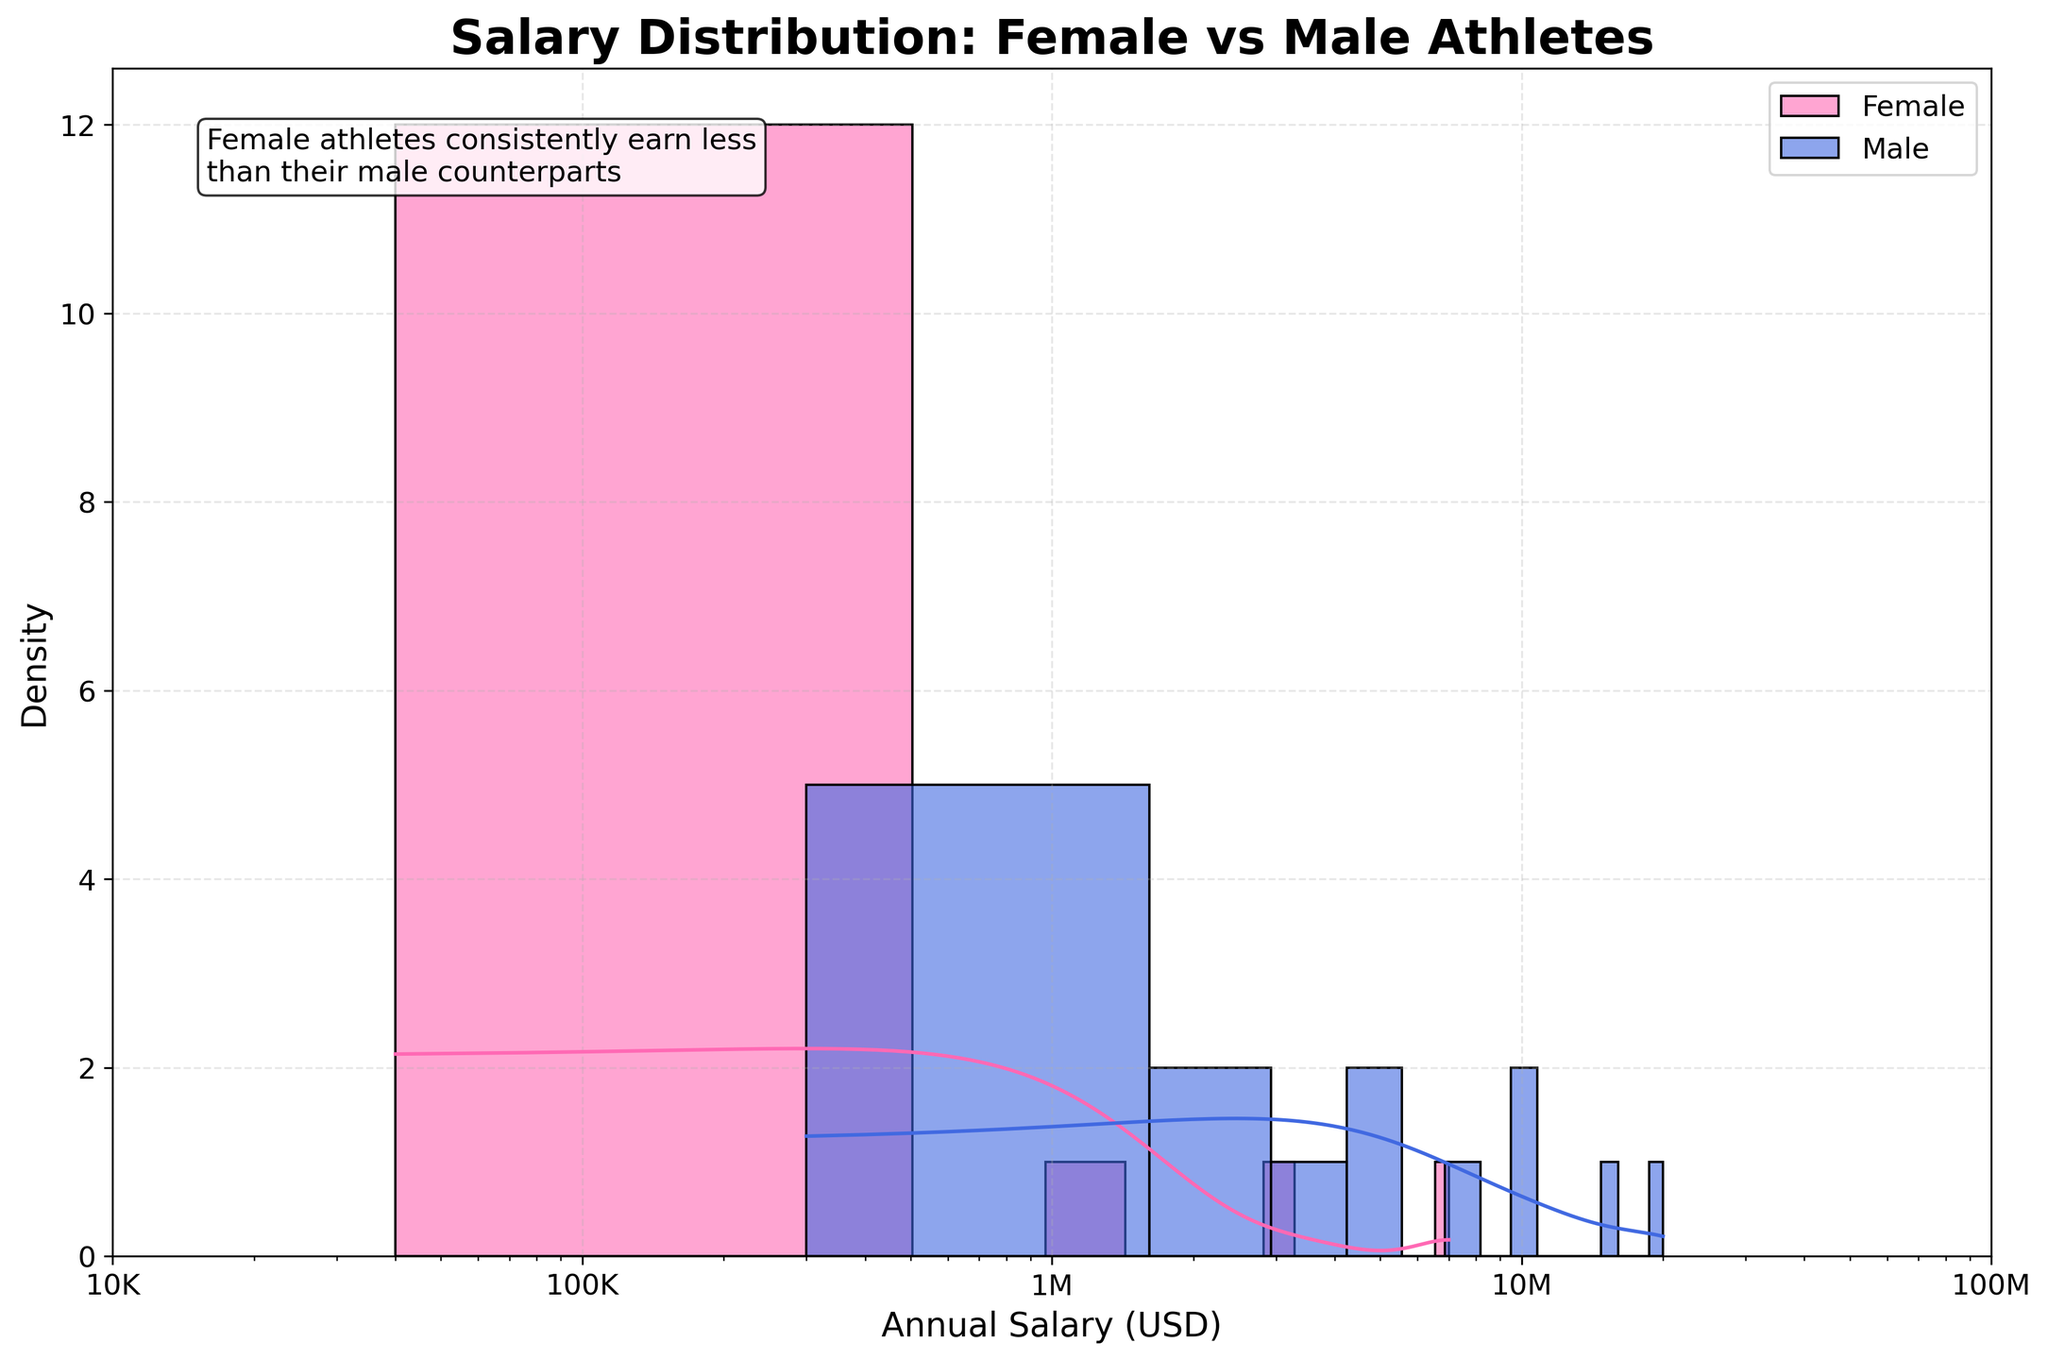What is the title of the plot? The title typically appears at the top of the plot, which gives a summary of what the plot represents. It reads 'Salary Distribution: Female vs Male Athletes'.
Answer: 'Salary Distribution: Female vs Male Athletes' What color represents the female athletes' salary distribution? The color used for female athletes' salary distribution appears in pink shade (#FF69B4). You can identify it by looking at the legend which labels the colors.
Answer: Pink What is the x-axis titled? The x-axis title is a label that describes what the x-axis represents. In this figure, it is labeled as 'Annual Salary (USD)'.
Answer: Annual Salary (USD) Which gender shows a higher overall annual salary range? By observing the x-axis range and the peaks of the KDE, the male athletes' salary distribution extends further to the right, indicating higher salaries.
Answer: Male What is the y-axis titled? The y-axis title tells us what the metric or measure is on the y-axis. It is labeled 'Density'.
Answer: Density How is the x-axis scaled in this figure? The x-axis scale in the plot is not linear but logarithmic. This is evident from the labels which are in powers of ten (10K, 100K, 1M, 10M, 100M).
Answer: Logarithmic What annotation is added to the figure and where is it placed? The annotation note is positioned in the upper left of the figure and reads: 'Female athletes consistently earn less than their male counterparts'. It is present to highlight a key insight from the plot.
Answer: 'Female athletes consistently earn less than their male counterparts' Which group has the higher density of lower salary ranges (below 100,000 USD)? By observing the KDE and the height of the bar in the histogram, the female athletes show a higher density in the lower salary ranges below 100,000 USD.
Answer: Female In which salary range is the KDE peak for male athletes? By identifying the highest point of the male KDE curve, you can see that the peak for male athletes is in the 1 million to 10 million USD range.
Answer: 1M to 10M USD How widely are the salaries distributed for female athletes in Basketball compared to male athletes in the same sport? The KDE curve and the histogram indicate the distribution of salaries. The range of salaries for female basketball players is concentrated below 500,000 USD, while for male basketball players, it extends up to 20,000,000 USD, showing wider variability.
Answer: Male athletes’ salaries are more widely distributed 